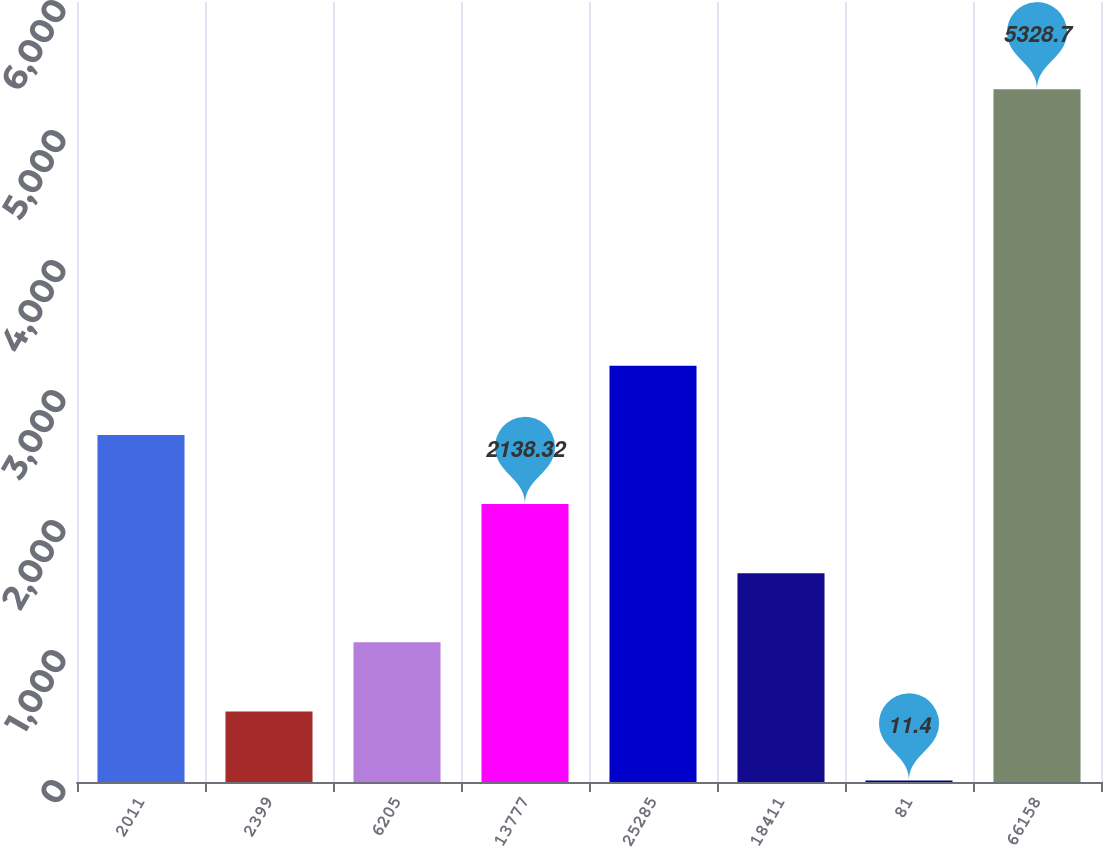Convert chart to OTSL. <chart><loc_0><loc_0><loc_500><loc_500><bar_chart><fcel>2011<fcel>2399<fcel>6205<fcel>13777<fcel>25285<fcel>18411<fcel>81<fcel>66158<nl><fcel>2670.05<fcel>543.13<fcel>1074.86<fcel>2138.32<fcel>3201.78<fcel>1606.59<fcel>11.4<fcel>5328.7<nl></chart> 